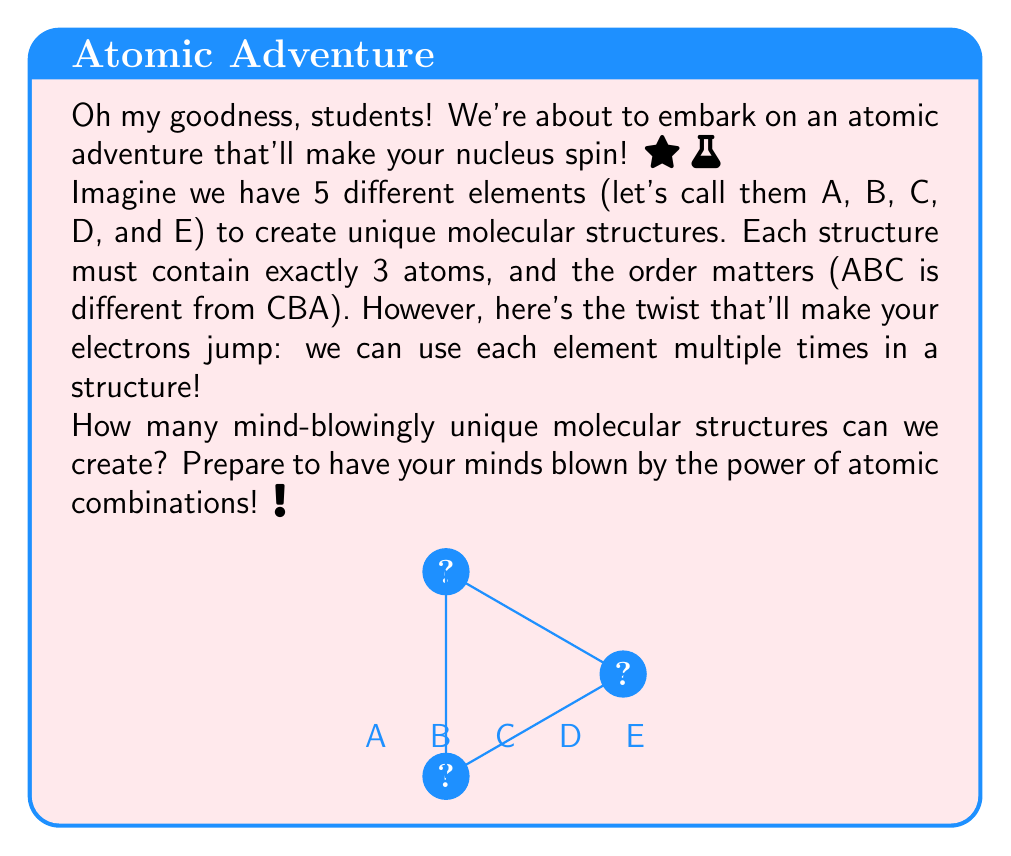Teach me how to tackle this problem. Let's break this down step-by-step, and you'll see how incredible this atomic arrangement is!

1) First, we need to understand what we're dealing with:
   - We have 5 different elements (A, B, C, D, E)
   - Each structure has 3 atoms
   - We can repeat elements
   - The order matters

2) This scenario is a perfect example of the multiplication principle in combinatorics!

3) For each position in our 3-atom structure:
   - We have 5 choices (any of the 5 elements)
   - This is true for all 3 positions, regardless of what we chose before

4) Therefore, we can calculate the total number of possibilities as:

   $$ \text{Total Structures} = 5 \times 5 \times 5 = 5^3 $$

5) Let's calculate this:
   $$ 5^3 = 5 \times 5 \times 5 = 125 $$

6) Isn't that amazing? From just 5 elements, we can create 125 unique structures!

This demonstrates the incredible diversity possible in molecular structures, even with a limited set of elements. It's this kind of combinatorial explosion that leads to the vast complexity we see in chemistry and biology!
Answer: $125$ 